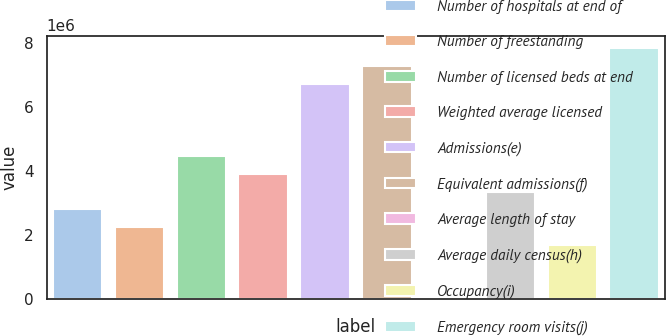<chart> <loc_0><loc_0><loc_500><loc_500><bar_chart><fcel>Number of hospitals at end of<fcel>Number of freestanding<fcel>Number of licensed beds at end<fcel>Weighted average licensed<fcel>Admissions(e)<fcel>Equivalent admissions(f)<fcel>Average length of stay<fcel>Average daily census(h)<fcel>Occupancy(i)<fcel>Emergency room visits(j)<nl><fcel>2.79675e+06<fcel>2.2374e+06<fcel>4.4748e+06<fcel>3.91545e+06<fcel>6.7122e+06<fcel>7.27155e+06<fcel>4.8<fcel>3.3561e+06<fcel>1.67805e+06<fcel>7.8309e+06<nl></chart> 